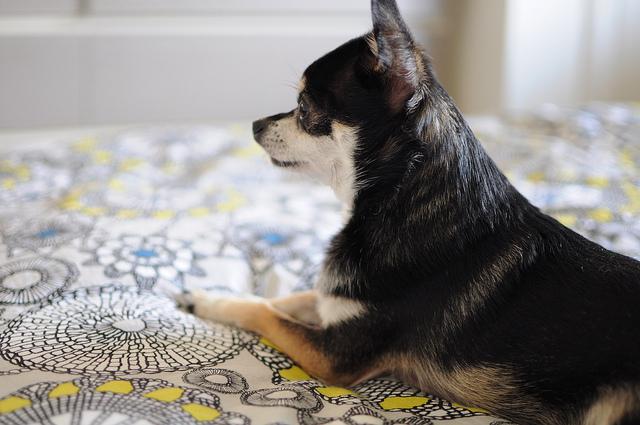What breed of dog is this?
Be succinct. Chihuahua. What color is the dog?
Concise answer only. Black. Is the dog on top of a bed?
Concise answer only. Yes. What is that animal?
Keep it brief. Dog. 